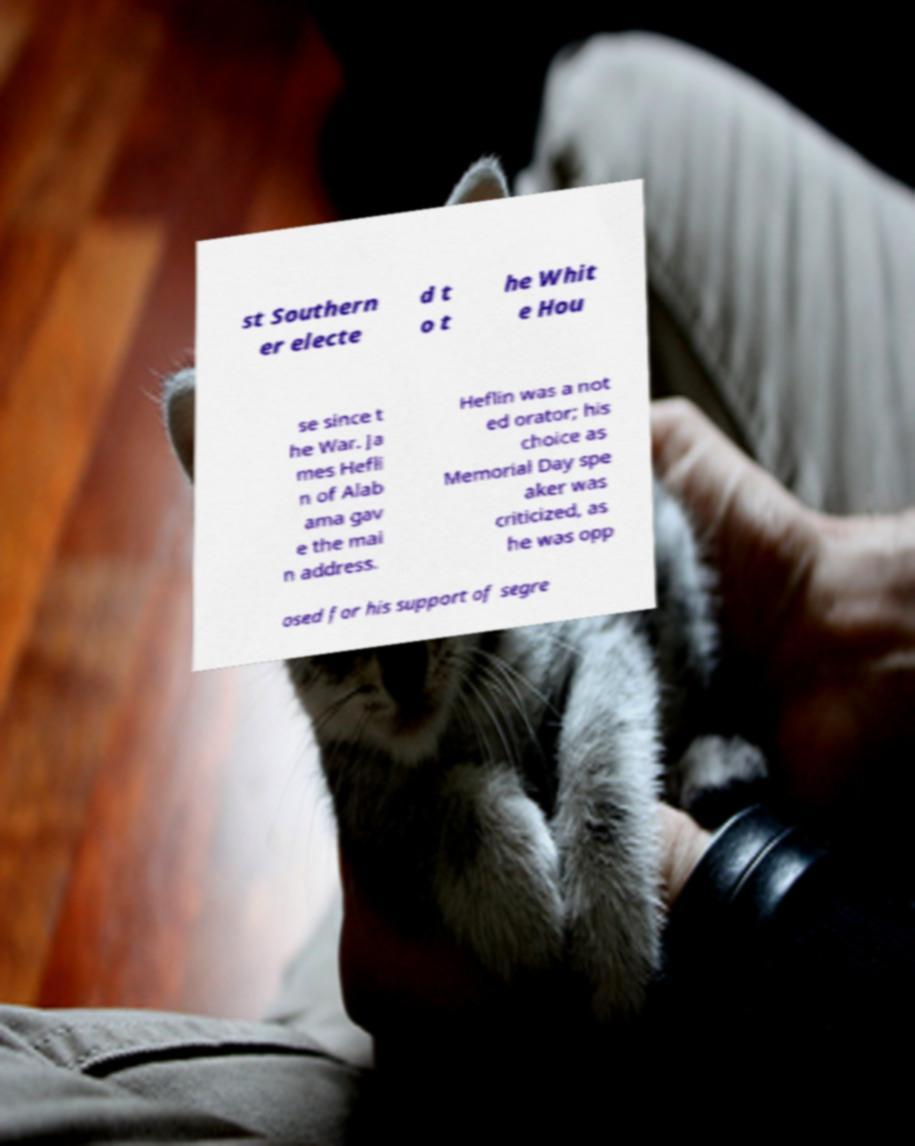Could you extract and type out the text from this image? st Southern er electe d t o t he Whit e Hou se since t he War. Ja mes Hefli n of Alab ama gav e the mai n address. Heflin was a not ed orator; his choice as Memorial Day spe aker was criticized, as he was opp osed for his support of segre 